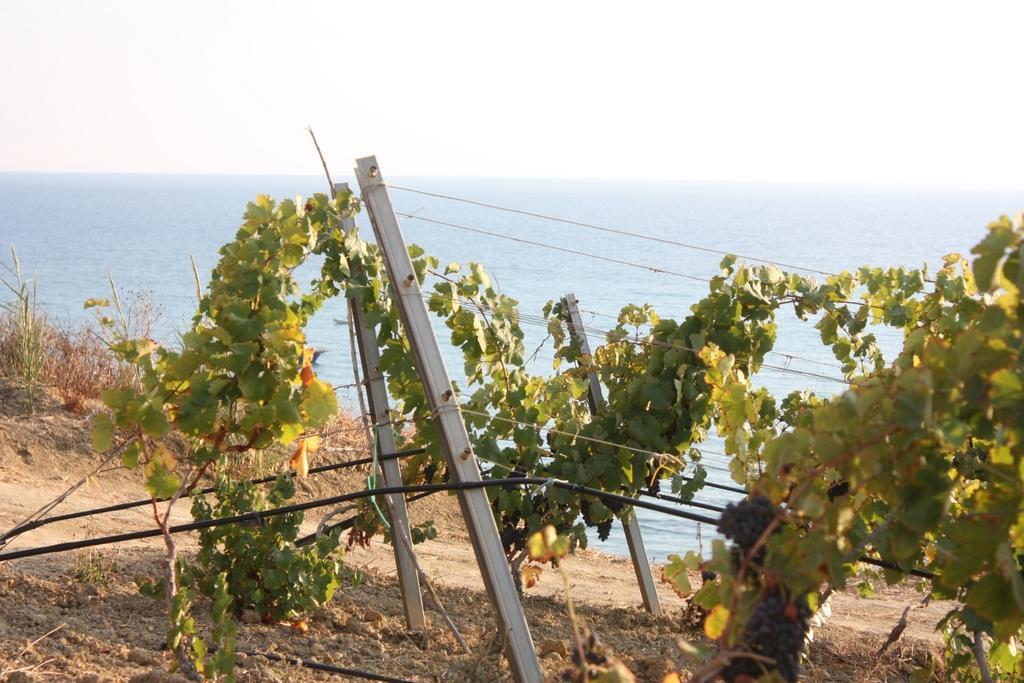What objects are present in the image that are attached to threads? There are poles in the image that are attached to threads. What are the poles near in the image? The poles are near plants in the image. Where are the poles located in relation to the ground? The poles are on the ground in the image. What type of vegetation can be seen in the background of the image? There is grass in the background of the image. How is the grass positioned in relation to the ground? The grass is on the ground in the image. What is visible in the background of the image beyond the grass? The sky is visible in the background of the image. What type of agreement is being signed in the image? There is no indication of an agreement or any signing activity in the image. Can you see any space-related objects or phenomena in the image? No, the image does not depict any space-related objects or phenomena. 